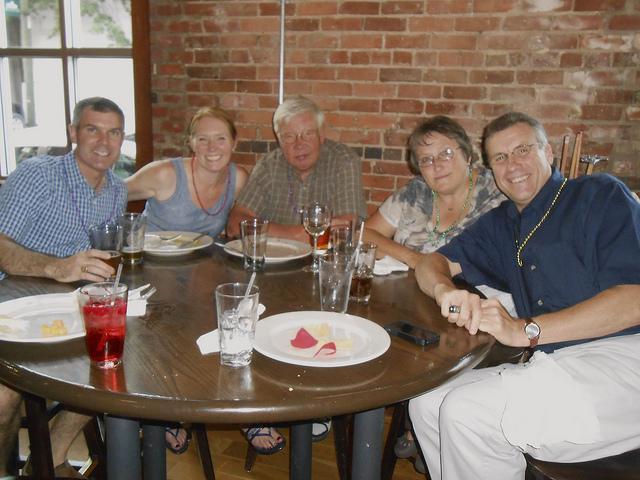How many people can be seen?
Give a very brief answer. 5. How many cups are in the picture?
Give a very brief answer. 2. How many ski poles is the person holding?
Give a very brief answer. 0. 